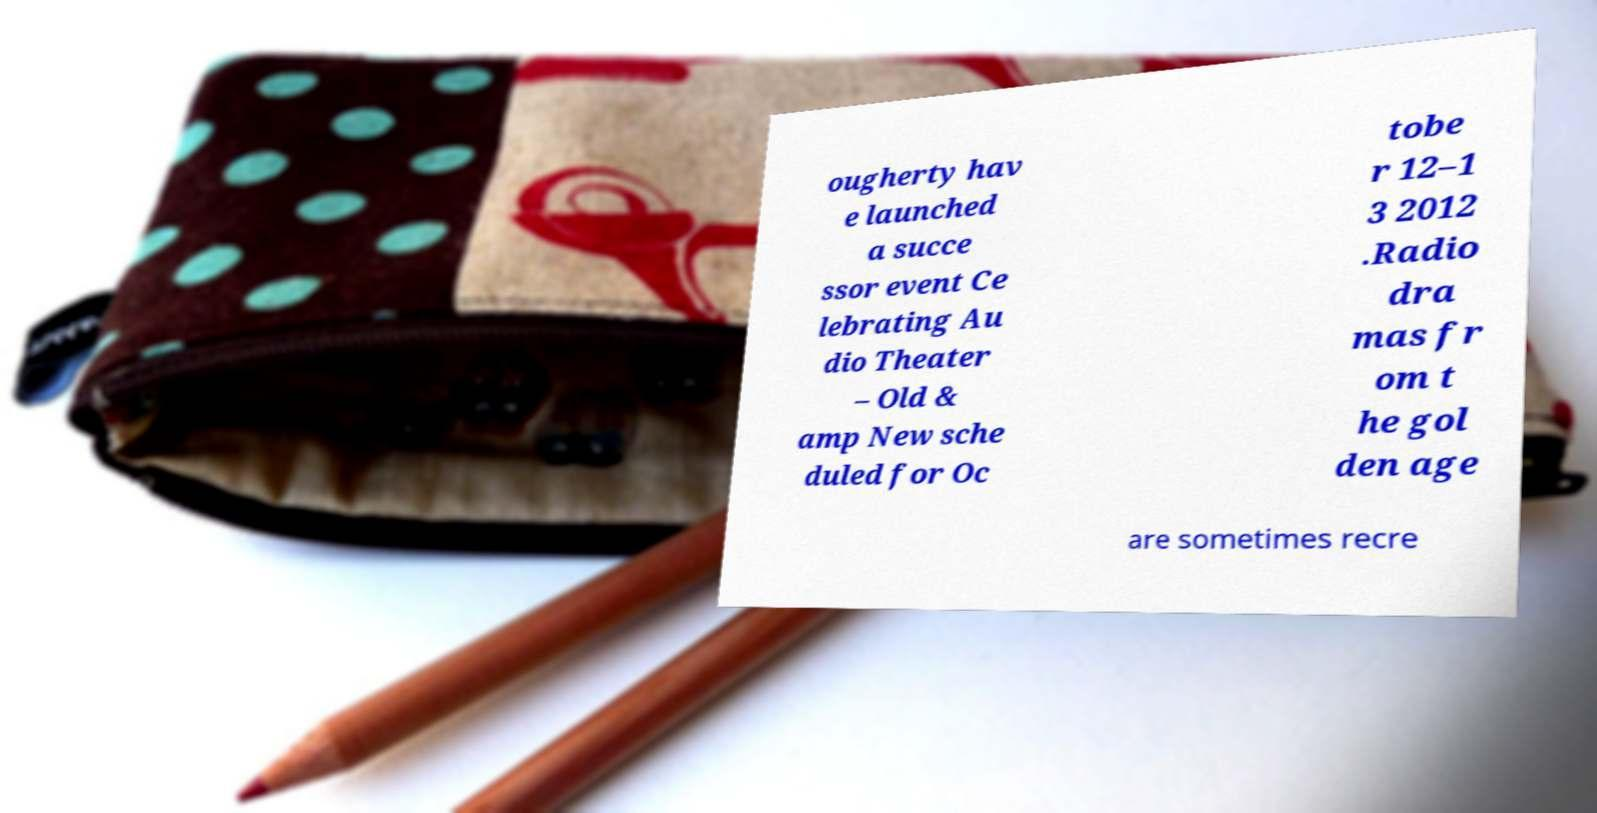What messages or text are displayed in this image? I need them in a readable, typed format. ougherty hav e launched a succe ssor event Ce lebrating Au dio Theater – Old & amp New sche duled for Oc tobe r 12–1 3 2012 .Radio dra mas fr om t he gol den age are sometimes recre 